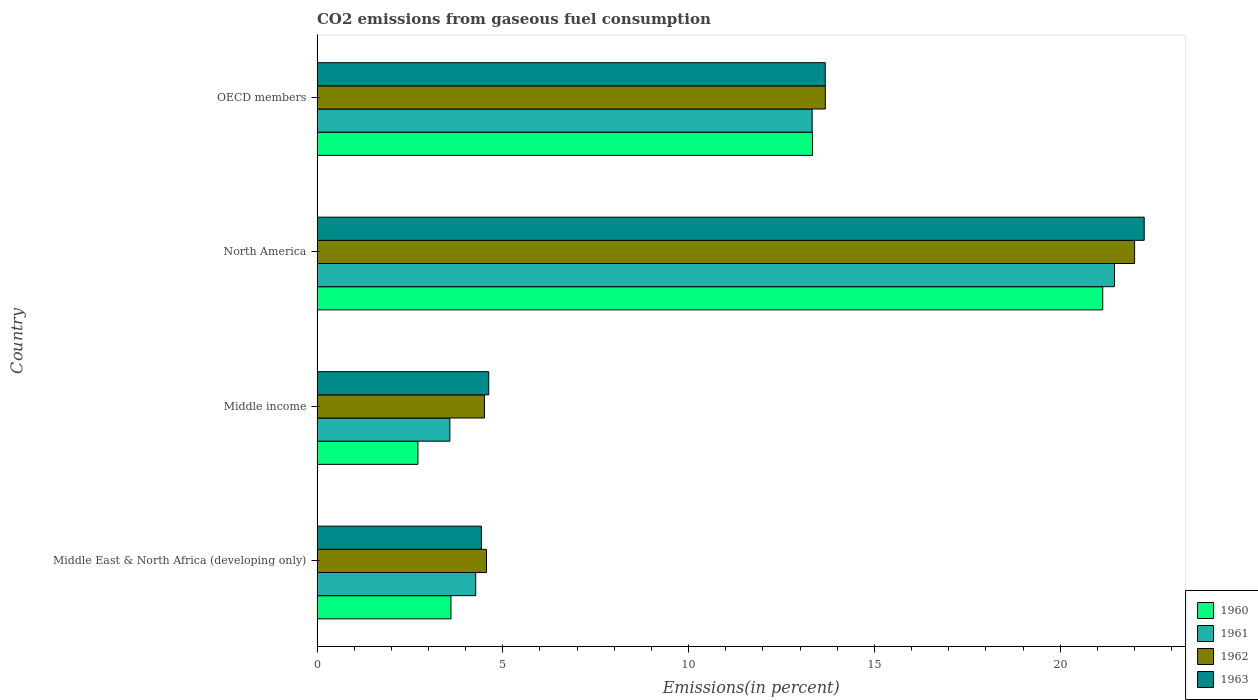How many different coloured bars are there?
Your answer should be compact. 4. How many groups of bars are there?
Your response must be concise. 4. Are the number of bars per tick equal to the number of legend labels?
Offer a very short reply. Yes. Are the number of bars on each tick of the Y-axis equal?
Make the answer very short. Yes. How many bars are there on the 4th tick from the top?
Offer a very short reply. 4. What is the label of the 2nd group of bars from the top?
Provide a short and direct response. North America. What is the total CO2 emitted in 1961 in OECD members?
Provide a succinct answer. 13.33. Across all countries, what is the maximum total CO2 emitted in 1961?
Provide a short and direct response. 21.46. Across all countries, what is the minimum total CO2 emitted in 1962?
Your answer should be compact. 4.5. In which country was the total CO2 emitted in 1963 maximum?
Keep it short and to the point. North America. In which country was the total CO2 emitted in 1960 minimum?
Your response must be concise. Middle income. What is the total total CO2 emitted in 1963 in the graph?
Ensure brevity in your answer.  44.98. What is the difference between the total CO2 emitted in 1961 in North America and that in OECD members?
Your answer should be compact. 8.14. What is the difference between the total CO2 emitted in 1963 in North America and the total CO2 emitted in 1961 in Middle East & North Africa (developing only)?
Your answer should be compact. 17.99. What is the average total CO2 emitted in 1961 per country?
Provide a succinct answer. 10.66. What is the difference between the total CO2 emitted in 1961 and total CO2 emitted in 1960 in Middle East & North Africa (developing only)?
Offer a terse response. 0.67. In how many countries, is the total CO2 emitted in 1963 greater than 14 %?
Ensure brevity in your answer.  1. What is the ratio of the total CO2 emitted in 1962 in Middle East & North Africa (developing only) to that in Middle income?
Provide a short and direct response. 1.01. Is the total CO2 emitted in 1963 in Middle East & North Africa (developing only) less than that in OECD members?
Your answer should be compact. Yes. What is the difference between the highest and the second highest total CO2 emitted in 1963?
Provide a succinct answer. 8.58. What is the difference between the highest and the lowest total CO2 emitted in 1962?
Ensure brevity in your answer.  17.5. Is it the case that in every country, the sum of the total CO2 emitted in 1961 and total CO2 emitted in 1963 is greater than the sum of total CO2 emitted in 1962 and total CO2 emitted in 1960?
Offer a terse response. No. What does the 3rd bar from the top in Middle East & North Africa (developing only) represents?
Your response must be concise. 1961. What is the difference between two consecutive major ticks on the X-axis?
Your answer should be very brief. 5. Are the values on the major ticks of X-axis written in scientific E-notation?
Provide a short and direct response. No. Does the graph contain grids?
Make the answer very short. No. What is the title of the graph?
Offer a very short reply. CO2 emissions from gaseous fuel consumption. What is the label or title of the X-axis?
Your answer should be very brief. Emissions(in percent). What is the Emissions(in percent) in 1960 in Middle East & North Africa (developing only)?
Give a very brief answer. 3.6. What is the Emissions(in percent) in 1961 in Middle East & North Africa (developing only)?
Provide a succinct answer. 4.27. What is the Emissions(in percent) of 1962 in Middle East & North Africa (developing only)?
Your answer should be very brief. 4.56. What is the Emissions(in percent) in 1963 in Middle East & North Africa (developing only)?
Ensure brevity in your answer.  4.42. What is the Emissions(in percent) in 1960 in Middle income?
Your response must be concise. 2.72. What is the Emissions(in percent) in 1961 in Middle income?
Make the answer very short. 3.57. What is the Emissions(in percent) in 1962 in Middle income?
Make the answer very short. 4.5. What is the Emissions(in percent) in 1963 in Middle income?
Offer a very short reply. 4.62. What is the Emissions(in percent) of 1960 in North America?
Offer a terse response. 21.15. What is the Emissions(in percent) of 1961 in North America?
Ensure brevity in your answer.  21.46. What is the Emissions(in percent) in 1962 in North America?
Your answer should be very brief. 22. What is the Emissions(in percent) in 1963 in North America?
Make the answer very short. 22.26. What is the Emissions(in percent) in 1960 in OECD members?
Ensure brevity in your answer.  13.33. What is the Emissions(in percent) of 1961 in OECD members?
Your response must be concise. 13.33. What is the Emissions(in percent) in 1962 in OECD members?
Offer a very short reply. 13.68. What is the Emissions(in percent) of 1963 in OECD members?
Give a very brief answer. 13.68. Across all countries, what is the maximum Emissions(in percent) of 1960?
Your answer should be very brief. 21.15. Across all countries, what is the maximum Emissions(in percent) of 1961?
Your response must be concise. 21.46. Across all countries, what is the maximum Emissions(in percent) of 1962?
Keep it short and to the point. 22. Across all countries, what is the maximum Emissions(in percent) in 1963?
Ensure brevity in your answer.  22.26. Across all countries, what is the minimum Emissions(in percent) in 1960?
Offer a terse response. 2.72. Across all countries, what is the minimum Emissions(in percent) of 1961?
Ensure brevity in your answer.  3.57. Across all countries, what is the minimum Emissions(in percent) in 1962?
Provide a short and direct response. 4.5. Across all countries, what is the minimum Emissions(in percent) in 1963?
Make the answer very short. 4.42. What is the total Emissions(in percent) in 1960 in the graph?
Ensure brevity in your answer.  40.8. What is the total Emissions(in percent) of 1961 in the graph?
Keep it short and to the point. 42.63. What is the total Emissions(in percent) of 1962 in the graph?
Ensure brevity in your answer.  44.75. What is the total Emissions(in percent) of 1963 in the graph?
Offer a very short reply. 44.98. What is the difference between the Emissions(in percent) of 1960 in Middle East & North Africa (developing only) and that in Middle income?
Keep it short and to the point. 0.89. What is the difference between the Emissions(in percent) in 1961 in Middle East & North Africa (developing only) and that in Middle income?
Offer a terse response. 0.7. What is the difference between the Emissions(in percent) in 1962 in Middle East & North Africa (developing only) and that in Middle income?
Offer a very short reply. 0.06. What is the difference between the Emissions(in percent) in 1963 in Middle East & North Africa (developing only) and that in Middle income?
Your answer should be compact. -0.2. What is the difference between the Emissions(in percent) in 1960 in Middle East & North Africa (developing only) and that in North America?
Ensure brevity in your answer.  -17.54. What is the difference between the Emissions(in percent) in 1961 in Middle East & North Africa (developing only) and that in North America?
Offer a terse response. -17.19. What is the difference between the Emissions(in percent) of 1962 in Middle East & North Africa (developing only) and that in North America?
Keep it short and to the point. -17.44. What is the difference between the Emissions(in percent) of 1963 in Middle East & North Africa (developing only) and that in North America?
Keep it short and to the point. -17.84. What is the difference between the Emissions(in percent) of 1960 in Middle East & North Africa (developing only) and that in OECD members?
Your answer should be very brief. -9.73. What is the difference between the Emissions(in percent) in 1961 in Middle East & North Africa (developing only) and that in OECD members?
Provide a short and direct response. -9.06. What is the difference between the Emissions(in percent) in 1962 in Middle East & North Africa (developing only) and that in OECD members?
Give a very brief answer. -9.12. What is the difference between the Emissions(in percent) of 1963 in Middle East & North Africa (developing only) and that in OECD members?
Your answer should be compact. -9.25. What is the difference between the Emissions(in percent) of 1960 in Middle income and that in North America?
Provide a succinct answer. -18.43. What is the difference between the Emissions(in percent) of 1961 in Middle income and that in North America?
Keep it short and to the point. -17.89. What is the difference between the Emissions(in percent) of 1962 in Middle income and that in North America?
Your answer should be very brief. -17.5. What is the difference between the Emissions(in percent) of 1963 in Middle income and that in North America?
Provide a succinct answer. -17.64. What is the difference between the Emissions(in percent) of 1960 in Middle income and that in OECD members?
Your answer should be very brief. -10.62. What is the difference between the Emissions(in percent) of 1961 in Middle income and that in OECD members?
Offer a terse response. -9.75. What is the difference between the Emissions(in percent) of 1962 in Middle income and that in OECD members?
Offer a terse response. -9.17. What is the difference between the Emissions(in percent) in 1963 in Middle income and that in OECD members?
Your answer should be compact. -9.06. What is the difference between the Emissions(in percent) in 1960 in North America and that in OECD members?
Offer a terse response. 7.81. What is the difference between the Emissions(in percent) of 1961 in North America and that in OECD members?
Provide a short and direct response. 8.14. What is the difference between the Emissions(in percent) in 1962 in North America and that in OECD members?
Your answer should be very brief. 8.32. What is the difference between the Emissions(in percent) of 1963 in North America and that in OECD members?
Your answer should be very brief. 8.58. What is the difference between the Emissions(in percent) of 1960 in Middle East & North Africa (developing only) and the Emissions(in percent) of 1961 in Middle income?
Keep it short and to the point. 0.03. What is the difference between the Emissions(in percent) in 1960 in Middle East & North Africa (developing only) and the Emissions(in percent) in 1962 in Middle income?
Your response must be concise. -0.9. What is the difference between the Emissions(in percent) in 1960 in Middle East & North Africa (developing only) and the Emissions(in percent) in 1963 in Middle income?
Your answer should be very brief. -1.02. What is the difference between the Emissions(in percent) of 1961 in Middle East & North Africa (developing only) and the Emissions(in percent) of 1962 in Middle income?
Provide a short and direct response. -0.24. What is the difference between the Emissions(in percent) in 1961 in Middle East & North Africa (developing only) and the Emissions(in percent) in 1963 in Middle income?
Your answer should be compact. -0.35. What is the difference between the Emissions(in percent) of 1962 in Middle East & North Africa (developing only) and the Emissions(in percent) of 1963 in Middle income?
Give a very brief answer. -0.06. What is the difference between the Emissions(in percent) in 1960 in Middle East & North Africa (developing only) and the Emissions(in percent) in 1961 in North America?
Your answer should be very brief. -17.86. What is the difference between the Emissions(in percent) of 1960 in Middle East & North Africa (developing only) and the Emissions(in percent) of 1962 in North America?
Make the answer very short. -18.4. What is the difference between the Emissions(in percent) in 1960 in Middle East & North Africa (developing only) and the Emissions(in percent) in 1963 in North America?
Ensure brevity in your answer.  -18.66. What is the difference between the Emissions(in percent) in 1961 in Middle East & North Africa (developing only) and the Emissions(in percent) in 1962 in North America?
Your answer should be very brief. -17.73. What is the difference between the Emissions(in percent) of 1961 in Middle East & North Africa (developing only) and the Emissions(in percent) of 1963 in North America?
Offer a terse response. -17.99. What is the difference between the Emissions(in percent) in 1962 in Middle East & North Africa (developing only) and the Emissions(in percent) in 1963 in North America?
Make the answer very short. -17.7. What is the difference between the Emissions(in percent) of 1960 in Middle East & North Africa (developing only) and the Emissions(in percent) of 1961 in OECD members?
Offer a terse response. -9.72. What is the difference between the Emissions(in percent) in 1960 in Middle East & North Africa (developing only) and the Emissions(in percent) in 1962 in OECD members?
Make the answer very short. -10.08. What is the difference between the Emissions(in percent) in 1960 in Middle East & North Africa (developing only) and the Emissions(in percent) in 1963 in OECD members?
Provide a succinct answer. -10.07. What is the difference between the Emissions(in percent) in 1961 in Middle East & North Africa (developing only) and the Emissions(in percent) in 1962 in OECD members?
Make the answer very short. -9.41. What is the difference between the Emissions(in percent) of 1961 in Middle East & North Africa (developing only) and the Emissions(in percent) of 1963 in OECD members?
Keep it short and to the point. -9.41. What is the difference between the Emissions(in percent) of 1962 in Middle East & North Africa (developing only) and the Emissions(in percent) of 1963 in OECD members?
Your response must be concise. -9.12. What is the difference between the Emissions(in percent) of 1960 in Middle income and the Emissions(in percent) of 1961 in North America?
Provide a succinct answer. -18.75. What is the difference between the Emissions(in percent) in 1960 in Middle income and the Emissions(in percent) in 1962 in North America?
Provide a short and direct response. -19.29. What is the difference between the Emissions(in percent) of 1960 in Middle income and the Emissions(in percent) of 1963 in North America?
Provide a short and direct response. -19.55. What is the difference between the Emissions(in percent) of 1961 in Middle income and the Emissions(in percent) of 1962 in North America?
Provide a succinct answer. -18.43. What is the difference between the Emissions(in percent) of 1961 in Middle income and the Emissions(in percent) of 1963 in North America?
Give a very brief answer. -18.69. What is the difference between the Emissions(in percent) of 1962 in Middle income and the Emissions(in percent) of 1963 in North America?
Your answer should be very brief. -17.76. What is the difference between the Emissions(in percent) in 1960 in Middle income and the Emissions(in percent) in 1961 in OECD members?
Your answer should be very brief. -10.61. What is the difference between the Emissions(in percent) in 1960 in Middle income and the Emissions(in percent) in 1962 in OECD members?
Your answer should be compact. -10.96. What is the difference between the Emissions(in percent) in 1960 in Middle income and the Emissions(in percent) in 1963 in OECD members?
Offer a terse response. -10.96. What is the difference between the Emissions(in percent) in 1961 in Middle income and the Emissions(in percent) in 1962 in OECD members?
Provide a succinct answer. -10.11. What is the difference between the Emissions(in percent) of 1961 in Middle income and the Emissions(in percent) of 1963 in OECD members?
Your response must be concise. -10.1. What is the difference between the Emissions(in percent) of 1962 in Middle income and the Emissions(in percent) of 1963 in OECD members?
Provide a succinct answer. -9.17. What is the difference between the Emissions(in percent) of 1960 in North America and the Emissions(in percent) of 1961 in OECD members?
Offer a terse response. 7.82. What is the difference between the Emissions(in percent) of 1960 in North America and the Emissions(in percent) of 1962 in OECD members?
Make the answer very short. 7.47. What is the difference between the Emissions(in percent) of 1960 in North America and the Emissions(in percent) of 1963 in OECD members?
Give a very brief answer. 7.47. What is the difference between the Emissions(in percent) in 1961 in North America and the Emissions(in percent) in 1962 in OECD members?
Ensure brevity in your answer.  7.78. What is the difference between the Emissions(in percent) of 1961 in North America and the Emissions(in percent) of 1963 in OECD members?
Give a very brief answer. 7.78. What is the difference between the Emissions(in percent) in 1962 in North America and the Emissions(in percent) in 1963 in OECD members?
Your answer should be very brief. 8.33. What is the average Emissions(in percent) in 1960 per country?
Offer a terse response. 10.2. What is the average Emissions(in percent) in 1961 per country?
Provide a succinct answer. 10.66. What is the average Emissions(in percent) in 1962 per country?
Keep it short and to the point. 11.19. What is the average Emissions(in percent) in 1963 per country?
Your response must be concise. 11.25. What is the difference between the Emissions(in percent) of 1960 and Emissions(in percent) of 1961 in Middle East & North Africa (developing only)?
Offer a very short reply. -0.67. What is the difference between the Emissions(in percent) in 1960 and Emissions(in percent) in 1962 in Middle East & North Africa (developing only)?
Your answer should be very brief. -0.96. What is the difference between the Emissions(in percent) of 1960 and Emissions(in percent) of 1963 in Middle East & North Africa (developing only)?
Your answer should be compact. -0.82. What is the difference between the Emissions(in percent) in 1961 and Emissions(in percent) in 1962 in Middle East & North Africa (developing only)?
Make the answer very short. -0.29. What is the difference between the Emissions(in percent) of 1961 and Emissions(in percent) of 1963 in Middle East & North Africa (developing only)?
Offer a very short reply. -0.15. What is the difference between the Emissions(in percent) in 1962 and Emissions(in percent) in 1963 in Middle East & North Africa (developing only)?
Ensure brevity in your answer.  0.14. What is the difference between the Emissions(in percent) in 1960 and Emissions(in percent) in 1961 in Middle income?
Provide a succinct answer. -0.86. What is the difference between the Emissions(in percent) in 1960 and Emissions(in percent) in 1962 in Middle income?
Ensure brevity in your answer.  -1.79. What is the difference between the Emissions(in percent) in 1960 and Emissions(in percent) in 1963 in Middle income?
Provide a succinct answer. -1.91. What is the difference between the Emissions(in percent) of 1961 and Emissions(in percent) of 1962 in Middle income?
Ensure brevity in your answer.  -0.93. What is the difference between the Emissions(in percent) of 1961 and Emissions(in percent) of 1963 in Middle income?
Provide a succinct answer. -1.05. What is the difference between the Emissions(in percent) in 1962 and Emissions(in percent) in 1963 in Middle income?
Keep it short and to the point. -0.12. What is the difference between the Emissions(in percent) in 1960 and Emissions(in percent) in 1961 in North America?
Ensure brevity in your answer.  -0.32. What is the difference between the Emissions(in percent) in 1960 and Emissions(in percent) in 1962 in North America?
Your answer should be compact. -0.86. What is the difference between the Emissions(in percent) in 1960 and Emissions(in percent) in 1963 in North America?
Keep it short and to the point. -1.12. What is the difference between the Emissions(in percent) of 1961 and Emissions(in percent) of 1962 in North America?
Offer a very short reply. -0.54. What is the difference between the Emissions(in percent) in 1961 and Emissions(in percent) in 1963 in North America?
Offer a very short reply. -0.8. What is the difference between the Emissions(in percent) in 1962 and Emissions(in percent) in 1963 in North America?
Keep it short and to the point. -0.26. What is the difference between the Emissions(in percent) of 1960 and Emissions(in percent) of 1961 in OECD members?
Your answer should be compact. 0.01. What is the difference between the Emissions(in percent) of 1960 and Emissions(in percent) of 1962 in OECD members?
Your response must be concise. -0.35. What is the difference between the Emissions(in percent) of 1960 and Emissions(in percent) of 1963 in OECD members?
Give a very brief answer. -0.34. What is the difference between the Emissions(in percent) of 1961 and Emissions(in percent) of 1962 in OECD members?
Keep it short and to the point. -0.35. What is the difference between the Emissions(in percent) of 1961 and Emissions(in percent) of 1963 in OECD members?
Keep it short and to the point. -0.35. What is the difference between the Emissions(in percent) in 1962 and Emissions(in percent) in 1963 in OECD members?
Offer a terse response. 0. What is the ratio of the Emissions(in percent) of 1960 in Middle East & North Africa (developing only) to that in Middle income?
Your answer should be compact. 1.33. What is the ratio of the Emissions(in percent) of 1961 in Middle East & North Africa (developing only) to that in Middle income?
Give a very brief answer. 1.19. What is the ratio of the Emissions(in percent) in 1962 in Middle East & North Africa (developing only) to that in Middle income?
Your answer should be compact. 1.01. What is the ratio of the Emissions(in percent) in 1963 in Middle East & North Africa (developing only) to that in Middle income?
Your answer should be very brief. 0.96. What is the ratio of the Emissions(in percent) in 1960 in Middle East & North Africa (developing only) to that in North America?
Make the answer very short. 0.17. What is the ratio of the Emissions(in percent) in 1961 in Middle East & North Africa (developing only) to that in North America?
Provide a succinct answer. 0.2. What is the ratio of the Emissions(in percent) in 1962 in Middle East & North Africa (developing only) to that in North America?
Offer a terse response. 0.21. What is the ratio of the Emissions(in percent) of 1963 in Middle East & North Africa (developing only) to that in North America?
Keep it short and to the point. 0.2. What is the ratio of the Emissions(in percent) in 1960 in Middle East & North Africa (developing only) to that in OECD members?
Provide a succinct answer. 0.27. What is the ratio of the Emissions(in percent) in 1961 in Middle East & North Africa (developing only) to that in OECD members?
Make the answer very short. 0.32. What is the ratio of the Emissions(in percent) of 1962 in Middle East & North Africa (developing only) to that in OECD members?
Keep it short and to the point. 0.33. What is the ratio of the Emissions(in percent) of 1963 in Middle East & North Africa (developing only) to that in OECD members?
Keep it short and to the point. 0.32. What is the ratio of the Emissions(in percent) in 1960 in Middle income to that in North America?
Your answer should be compact. 0.13. What is the ratio of the Emissions(in percent) in 1961 in Middle income to that in North America?
Offer a terse response. 0.17. What is the ratio of the Emissions(in percent) of 1962 in Middle income to that in North America?
Offer a terse response. 0.2. What is the ratio of the Emissions(in percent) in 1963 in Middle income to that in North America?
Provide a succinct answer. 0.21. What is the ratio of the Emissions(in percent) of 1960 in Middle income to that in OECD members?
Give a very brief answer. 0.2. What is the ratio of the Emissions(in percent) in 1961 in Middle income to that in OECD members?
Keep it short and to the point. 0.27. What is the ratio of the Emissions(in percent) of 1962 in Middle income to that in OECD members?
Make the answer very short. 0.33. What is the ratio of the Emissions(in percent) in 1963 in Middle income to that in OECD members?
Ensure brevity in your answer.  0.34. What is the ratio of the Emissions(in percent) of 1960 in North America to that in OECD members?
Make the answer very short. 1.59. What is the ratio of the Emissions(in percent) of 1961 in North America to that in OECD members?
Offer a very short reply. 1.61. What is the ratio of the Emissions(in percent) of 1962 in North America to that in OECD members?
Make the answer very short. 1.61. What is the ratio of the Emissions(in percent) of 1963 in North America to that in OECD members?
Give a very brief answer. 1.63. What is the difference between the highest and the second highest Emissions(in percent) of 1960?
Your answer should be very brief. 7.81. What is the difference between the highest and the second highest Emissions(in percent) in 1961?
Your response must be concise. 8.14. What is the difference between the highest and the second highest Emissions(in percent) of 1962?
Ensure brevity in your answer.  8.32. What is the difference between the highest and the second highest Emissions(in percent) in 1963?
Provide a short and direct response. 8.58. What is the difference between the highest and the lowest Emissions(in percent) in 1960?
Offer a terse response. 18.43. What is the difference between the highest and the lowest Emissions(in percent) in 1961?
Give a very brief answer. 17.89. What is the difference between the highest and the lowest Emissions(in percent) in 1962?
Ensure brevity in your answer.  17.5. What is the difference between the highest and the lowest Emissions(in percent) in 1963?
Keep it short and to the point. 17.84. 